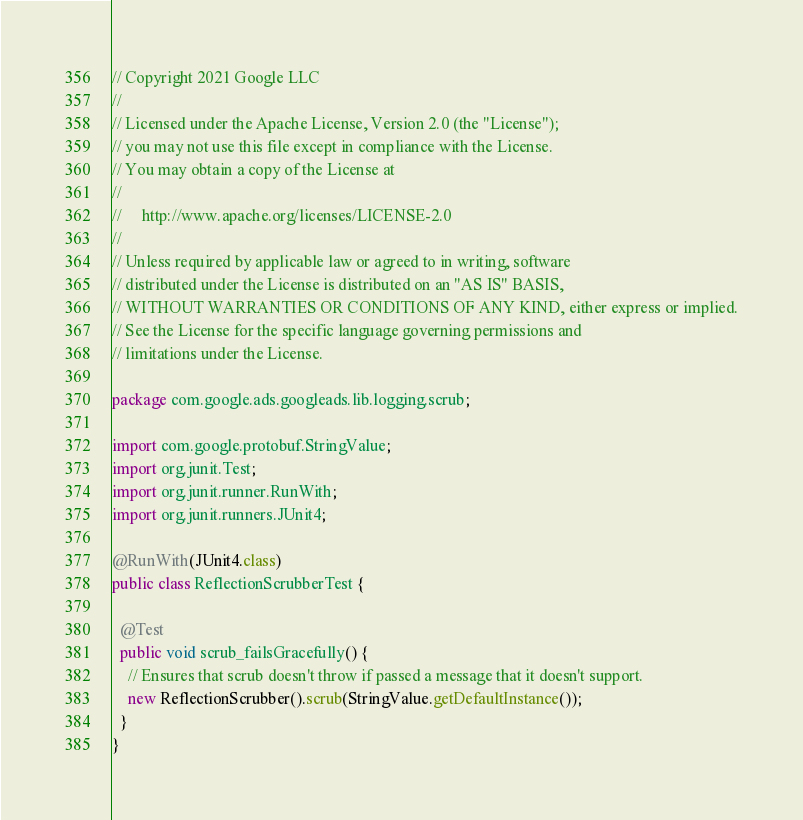Convert code to text. <code><loc_0><loc_0><loc_500><loc_500><_Java_>// Copyright 2021 Google LLC
//
// Licensed under the Apache License, Version 2.0 (the "License");
// you may not use this file except in compliance with the License.
// You may obtain a copy of the License at
//
//     http://www.apache.org/licenses/LICENSE-2.0
//
// Unless required by applicable law or agreed to in writing, software
// distributed under the License is distributed on an "AS IS" BASIS,
// WITHOUT WARRANTIES OR CONDITIONS OF ANY KIND, either express or implied.
// See the License for the specific language governing permissions and
// limitations under the License.

package com.google.ads.googleads.lib.logging.scrub;

import com.google.protobuf.StringValue;
import org.junit.Test;
import org.junit.runner.RunWith;
import org.junit.runners.JUnit4;

@RunWith(JUnit4.class)
public class ReflectionScrubberTest {

  @Test
  public void scrub_failsGracefully() {
    // Ensures that scrub doesn't throw if passed a message that it doesn't support.
    new ReflectionScrubber().scrub(StringValue.getDefaultInstance());
  }
}
</code> 